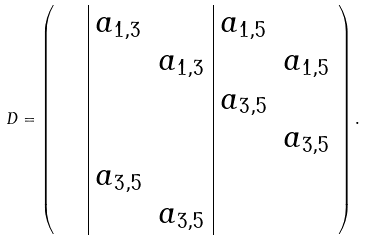<formula> <loc_0><loc_0><loc_500><loc_500>D = \left ( \begin{array} { c c | c c | c c } & & a _ { 1 , 3 } & & a _ { 1 , 5 } & \\ & & & a _ { 1 , 3 } & & a _ { 1 , 5 } \\ & & & & a _ { 3 , 5 } & \\ & & & & & a _ { 3 , 5 } \\ & & a _ { 3 , 5 } & & & \\ & & & a _ { 3 , 5 } & & \\ \end{array} \right ) .</formula> 